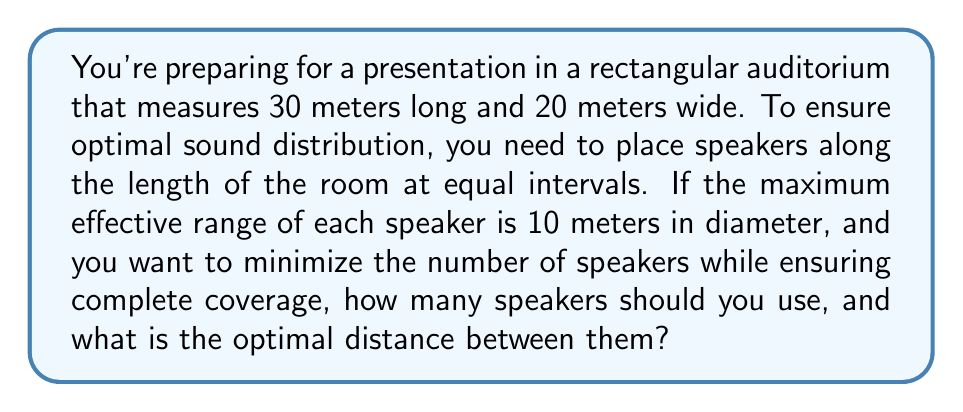Give your solution to this math problem. Let's approach this step-by-step:

1) First, we need to determine the coverage area of each speaker. The diameter is 10 meters, so the radius is 5 meters.

2) We want to place speakers along the length of the room (30 meters) to cover the entire width (20 meters).

3) To ensure complete coverage across the width, the speakers must be placed no more than 10 meters apart (the diameter of their coverage).

4) Let's say we use $n$ speakers. The distance between adjacent speakers, including the first and last speakers to the walls, would be:

   $$\frac{30}{n+1} = d$$

   where $d$ is the distance between speakers.

5) For complete coverage, we need:

   $$d \leq 10$$

6) Substituting:

   $$\frac{30}{n+1} \leq 10$$

7) Solving for $n$:

   $$n+1 \geq 3$$
   $$n \geq 2$$

8) The smallest integer value of $n$ that satisfies this inequality is 2.

9) With 2 speakers, the distance between them would be:

   $$d = \frac{30}{2+1} = 10\text{ meters}$$

This setup provides complete coverage with the minimum number of speakers.

[asy]
size(300,200);
draw((0,0)--(300,0)--(300,200)--(0,200)--cycle);
dot((100,100));
dot((200,100));
draw(Circle((100,100),50));
draw(Circle((200,100),50));
label("30m", (150,0), S);
label("20m", (300,100), E);
label("10m", (150,100), N);
[/asy]
Answer: 2 speakers, 10 meters apart 